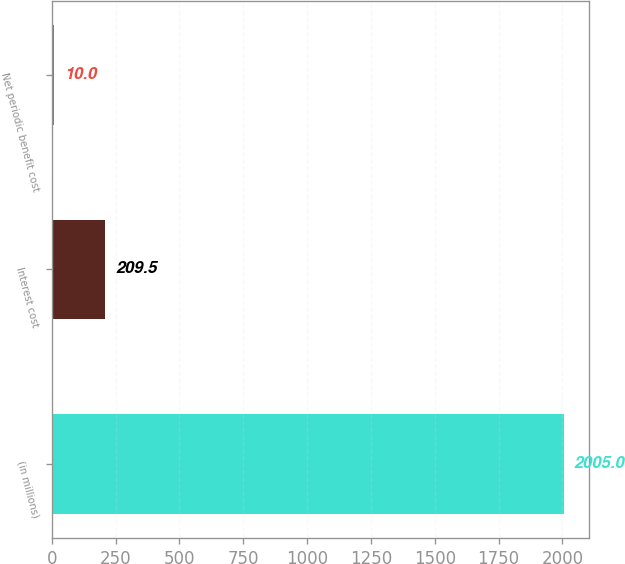Convert chart. <chart><loc_0><loc_0><loc_500><loc_500><bar_chart><fcel>(in millions)<fcel>Interest cost<fcel>Net periodic benefit cost<nl><fcel>2005<fcel>209.5<fcel>10<nl></chart> 